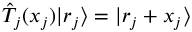<formula> <loc_0><loc_0><loc_500><loc_500>{ \hat { T } } _ { j } ( x _ { j } ) | r _ { j } \rangle = | r _ { j } + x _ { j } \rangle</formula> 